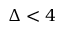<formula> <loc_0><loc_0><loc_500><loc_500>\Delta < 4</formula> 